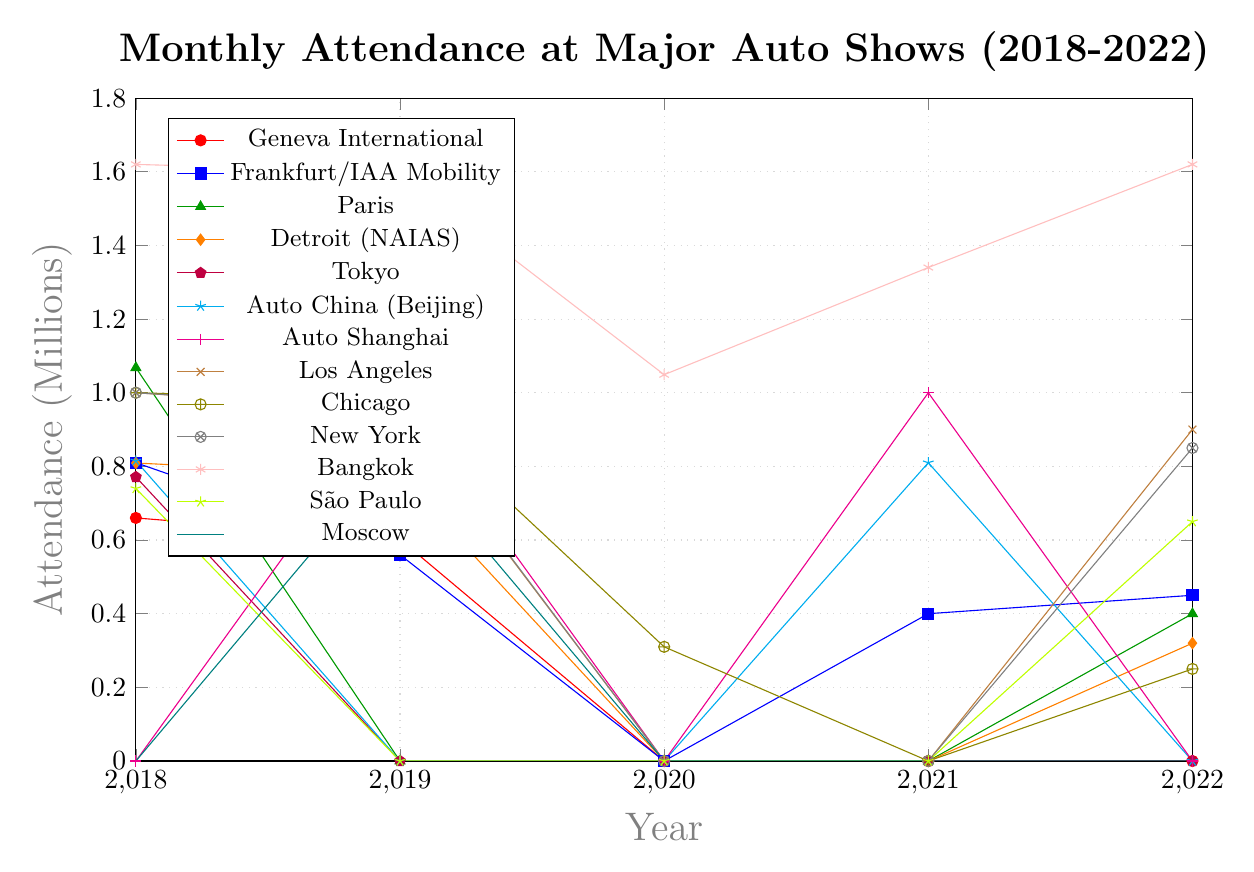Which auto show had the highest attendance in 2022? Identify the data points for 2022 and compare them. The Bangkok International Motor Show had the highest attendance at 1.62 million.
Answer: Bangkok International Motor Show How did the attendance at the Frankfurt Motor Show in 2018 compare to 2022? Identify the attendance for the Frankfurt Motor Show in 2018 and 2022. In 2018, it was 0.81 million, whereas in 2022, it was 0.45 million. So, the attendance decreased by 0.36 million.
Answer: Decreased by 0.36 million Which years saw zero attendance for the Geneva International Motor Show? Locate the data points for the Geneva International Motor Show. It had zero attendance in 2020, 2021, and 2022.
Answer: 2020, 2021, 2022 Compare the attendance trends between Auto China (Beijing) and Auto Shanghai over the 5 years. Compare the data points for both auto shows from 2018 to 2022. Auto China had attendance in 2018 and 2021, while Auto Shanghai had attendance in 2019 and 2021.
Answer: Auto China: 2018, 2021; Auto Shanghai: 2019, 2021 How much higher was the attendance at the Bangkok Motor Show in 2022 compared to the next highest event in that year? Locate the Bangkok attendance for 2022 (1.62 million) and find the next highest, which is Los Angeles Auto Show (0.9 million). Subtract to find the difference: 1.62 - 0.9 = 0.72 million.
Answer: 0.72 million What was the overall trend in attendance for the Chicago Auto Show from 2018 to 2022? Review the data points for the Chicago Auto Show for each year. Attendance starts at 1 million in 2018, slightly increases to 0.98 million in 2019, drops drastically to 0.31 million in 2020, is absent in 2021, and rises slightly to 0.25 million in 2022.
Answer: Decreasing trend Which event had the largest drop in attendance from its peak value between 2018 and 2022? Identify the highest attendance for each event and the subsequent lowest attendance. The Chicago Auto Show dropped from 1 million in 2018 to 0.25 million in 2022, a drop of 0.75 million.
Answer: Chicago Auto Show Was there consistent attendance for any event from 2018 to 2022? Check each event's attendance over the 5 years. Only the Bangkok International Motor Show showed consistent attendance with minor fluctuations but no zero-attendance years.
Answer: Bangkok International Motor Show 